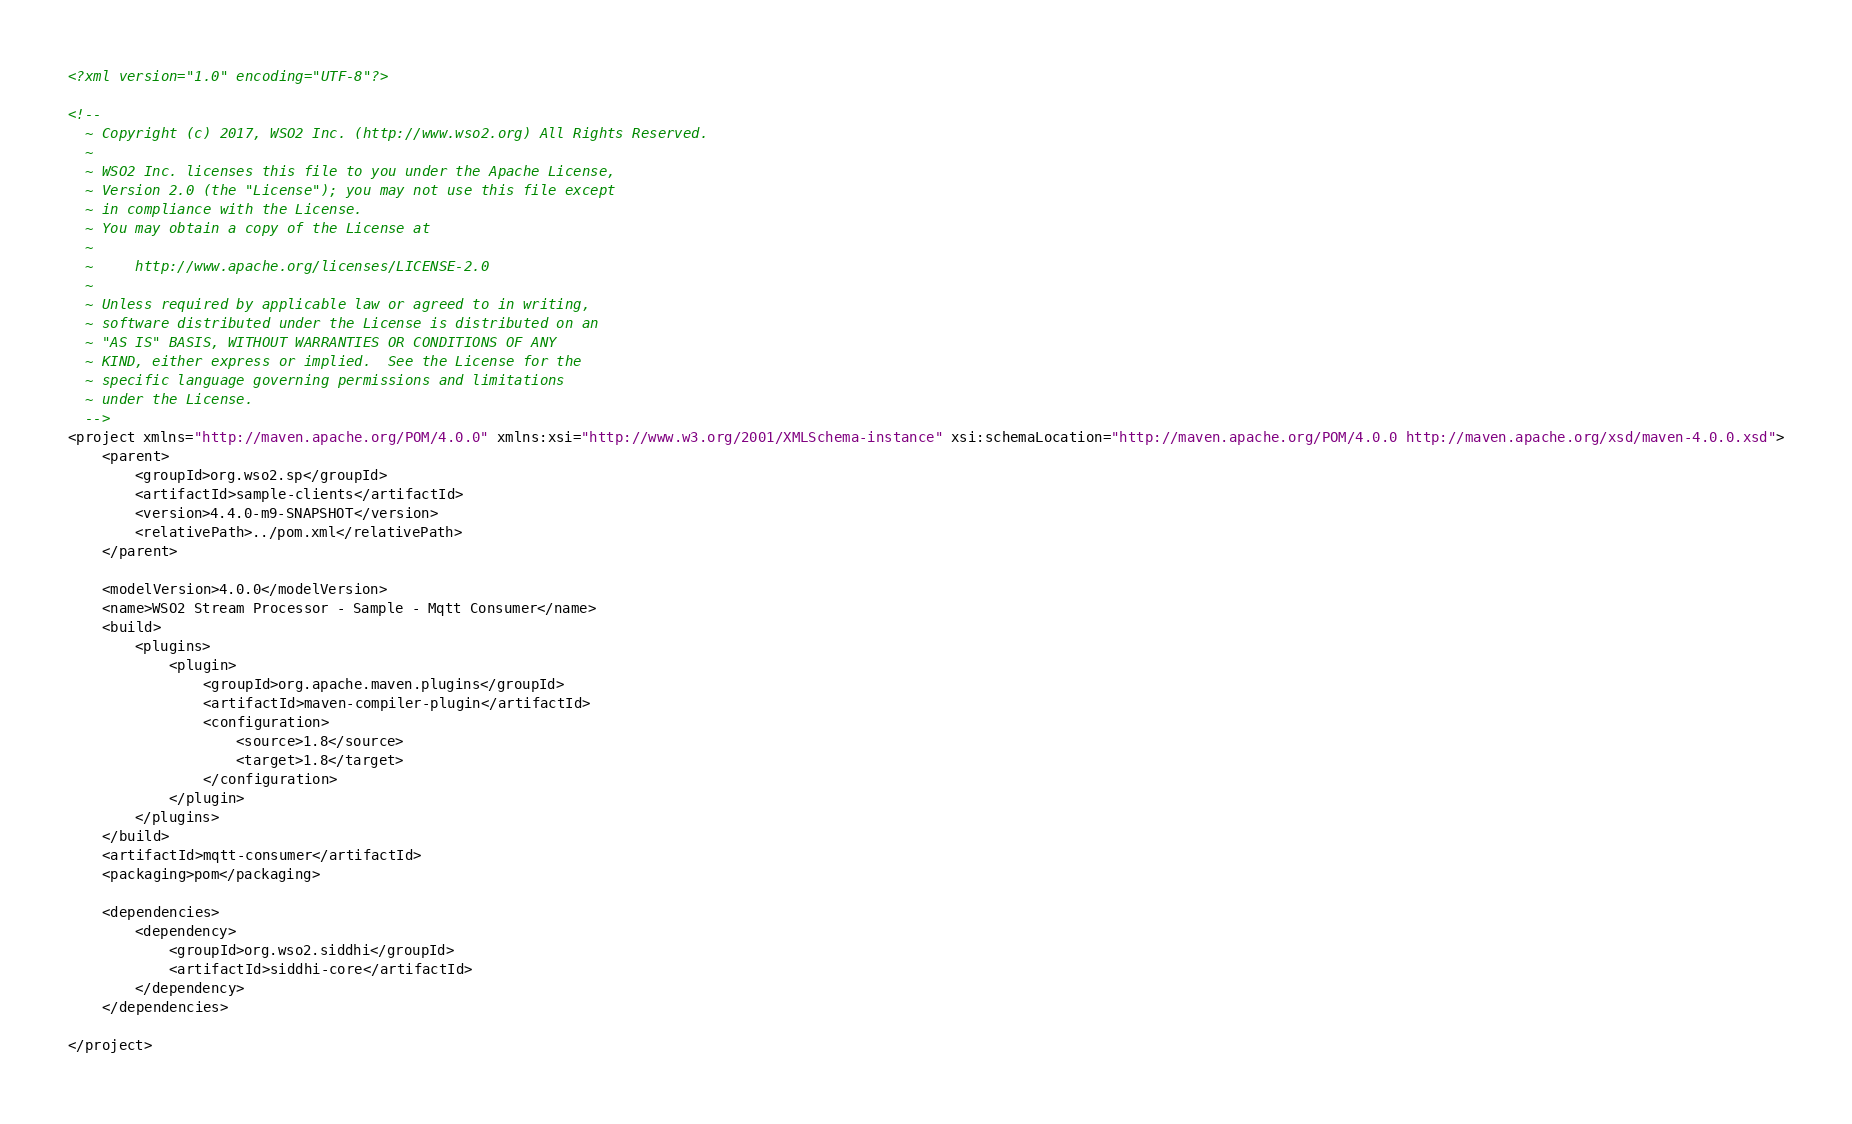<code> <loc_0><loc_0><loc_500><loc_500><_XML_><?xml version="1.0" encoding="UTF-8"?>

<!--
  ~ Copyright (c) 2017, WSO2 Inc. (http://www.wso2.org) All Rights Reserved.
  ~
  ~ WSO2 Inc. licenses this file to you under the Apache License,
  ~ Version 2.0 (the "License"); you may not use this file except
  ~ in compliance with the License.
  ~ You may obtain a copy of the License at
  ~
  ~     http://www.apache.org/licenses/LICENSE-2.0
  ~
  ~ Unless required by applicable law or agreed to in writing,
  ~ software distributed under the License is distributed on an
  ~ "AS IS" BASIS, WITHOUT WARRANTIES OR CONDITIONS OF ANY
  ~ KIND, either express or implied.  See the License for the
  ~ specific language governing permissions and limitations
  ~ under the License.
  -->
<project xmlns="http://maven.apache.org/POM/4.0.0" xmlns:xsi="http://www.w3.org/2001/XMLSchema-instance" xsi:schemaLocation="http://maven.apache.org/POM/4.0.0 http://maven.apache.org/xsd/maven-4.0.0.xsd">
    <parent>
        <groupId>org.wso2.sp</groupId>
        <artifactId>sample-clients</artifactId>
        <version>4.4.0-m9-SNAPSHOT</version>
        <relativePath>../pom.xml</relativePath>
    </parent>

    <modelVersion>4.0.0</modelVersion>
    <name>WSO2 Stream Processor - Sample - Mqtt Consumer</name>
    <build>
        <plugins>
            <plugin>
                <groupId>org.apache.maven.plugins</groupId>
                <artifactId>maven-compiler-plugin</artifactId>
                <configuration>
                    <source>1.8</source>
                    <target>1.8</target>
                </configuration>
            </plugin>
        </plugins>
    </build>
    <artifactId>mqtt-consumer</artifactId>
    <packaging>pom</packaging>

    <dependencies>
        <dependency>
            <groupId>org.wso2.siddhi</groupId>
            <artifactId>siddhi-core</artifactId>
        </dependency>
    </dependencies>

</project>
</code> 